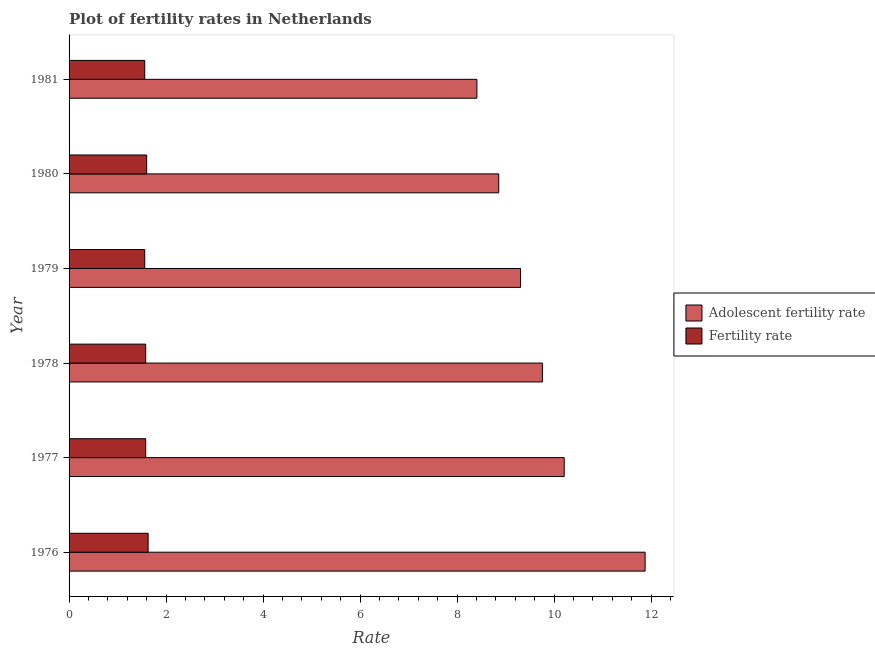How many groups of bars are there?
Your response must be concise. 6. Are the number of bars per tick equal to the number of legend labels?
Ensure brevity in your answer.  Yes. How many bars are there on the 2nd tick from the top?
Offer a very short reply. 2. What is the label of the 4th group of bars from the top?
Your answer should be very brief. 1978. In how many cases, is the number of bars for a given year not equal to the number of legend labels?
Your response must be concise. 0. What is the adolescent fertility rate in 1978?
Give a very brief answer. 9.76. Across all years, what is the maximum fertility rate?
Ensure brevity in your answer.  1.63. Across all years, what is the minimum fertility rate?
Make the answer very short. 1.56. In which year was the adolescent fertility rate maximum?
Make the answer very short. 1976. What is the total fertility rate in the graph?
Your response must be concise. 9.51. What is the difference between the fertility rate in 1976 and that in 1979?
Provide a short and direct response. 0.07. What is the difference between the fertility rate in 1976 and the adolescent fertility rate in 1978?
Provide a short and direct response. -8.13. What is the average fertility rate per year?
Provide a short and direct response. 1.58. In the year 1976, what is the difference between the adolescent fertility rate and fertility rate?
Make the answer very short. 10.25. In how many years, is the fertility rate greater than 6 ?
Your response must be concise. 0. What is the ratio of the fertility rate in 1976 to that in 1981?
Provide a short and direct response. 1.04. Is the fertility rate in 1976 less than that in 1977?
Ensure brevity in your answer.  No. Is the difference between the adolescent fertility rate in 1978 and 1981 greater than the difference between the fertility rate in 1978 and 1981?
Your answer should be very brief. Yes. What is the difference between the highest and the second highest adolescent fertility rate?
Ensure brevity in your answer.  1.67. What is the difference between the highest and the lowest fertility rate?
Give a very brief answer. 0.07. What does the 2nd bar from the top in 1980 represents?
Make the answer very short. Adolescent fertility rate. What does the 1st bar from the bottom in 1977 represents?
Your answer should be very brief. Adolescent fertility rate. Are all the bars in the graph horizontal?
Your answer should be compact. Yes. Does the graph contain grids?
Ensure brevity in your answer.  No. How many legend labels are there?
Keep it short and to the point. 2. How are the legend labels stacked?
Provide a succinct answer. Vertical. What is the title of the graph?
Ensure brevity in your answer.  Plot of fertility rates in Netherlands. What is the label or title of the X-axis?
Your answer should be compact. Rate. What is the label or title of the Y-axis?
Your answer should be very brief. Year. What is the Rate of Adolescent fertility rate in 1976?
Provide a succinct answer. 11.88. What is the Rate in Fertility rate in 1976?
Your response must be concise. 1.63. What is the Rate of Adolescent fertility rate in 1977?
Your answer should be very brief. 10.21. What is the Rate of Fertility rate in 1977?
Ensure brevity in your answer.  1.58. What is the Rate in Adolescent fertility rate in 1978?
Keep it short and to the point. 9.76. What is the Rate in Fertility rate in 1978?
Give a very brief answer. 1.58. What is the Rate in Adolescent fertility rate in 1979?
Provide a succinct answer. 9.31. What is the Rate in Fertility rate in 1979?
Keep it short and to the point. 1.56. What is the Rate in Adolescent fertility rate in 1980?
Make the answer very short. 8.86. What is the Rate of Fertility rate in 1980?
Your answer should be compact. 1.6. What is the Rate in Adolescent fertility rate in 1981?
Offer a very short reply. 8.41. What is the Rate in Fertility rate in 1981?
Your answer should be very brief. 1.56. Across all years, what is the maximum Rate of Adolescent fertility rate?
Provide a short and direct response. 11.88. Across all years, what is the maximum Rate of Fertility rate?
Make the answer very short. 1.63. Across all years, what is the minimum Rate of Adolescent fertility rate?
Offer a terse response. 8.41. Across all years, what is the minimum Rate of Fertility rate?
Offer a very short reply. 1.56. What is the total Rate in Adolescent fertility rate in the graph?
Offer a terse response. 58.42. What is the total Rate of Fertility rate in the graph?
Offer a very short reply. 9.51. What is the difference between the Rate of Adolescent fertility rate in 1976 and that in 1977?
Provide a succinct answer. 1.67. What is the difference between the Rate of Adolescent fertility rate in 1976 and that in 1978?
Your answer should be compact. 2.12. What is the difference between the Rate in Adolescent fertility rate in 1976 and that in 1979?
Offer a very short reply. 2.57. What is the difference between the Rate of Fertility rate in 1976 and that in 1979?
Offer a very short reply. 0.07. What is the difference between the Rate of Adolescent fertility rate in 1976 and that in 1980?
Provide a short and direct response. 3.02. What is the difference between the Rate in Fertility rate in 1976 and that in 1980?
Provide a short and direct response. 0.03. What is the difference between the Rate of Adolescent fertility rate in 1976 and that in 1981?
Your response must be concise. 3.47. What is the difference between the Rate of Fertility rate in 1976 and that in 1981?
Provide a short and direct response. 0.07. What is the difference between the Rate in Adolescent fertility rate in 1977 and that in 1978?
Provide a succinct answer. 0.45. What is the difference between the Rate in Adolescent fertility rate in 1977 and that in 1979?
Offer a terse response. 0.9. What is the difference between the Rate in Adolescent fertility rate in 1977 and that in 1980?
Ensure brevity in your answer.  1.35. What is the difference between the Rate in Fertility rate in 1977 and that in 1980?
Give a very brief answer. -0.02. What is the difference between the Rate of Adolescent fertility rate in 1978 and that in 1979?
Offer a terse response. 0.45. What is the difference between the Rate in Fertility rate in 1978 and that in 1980?
Ensure brevity in your answer.  -0.02. What is the difference between the Rate of Adolescent fertility rate in 1978 and that in 1981?
Your response must be concise. 1.35. What is the difference between the Rate in Fertility rate in 1978 and that in 1981?
Offer a very short reply. 0.02. What is the difference between the Rate in Adolescent fertility rate in 1979 and that in 1980?
Your answer should be compact. 0.45. What is the difference between the Rate of Fertility rate in 1979 and that in 1980?
Keep it short and to the point. -0.04. What is the difference between the Rate in Adolescent fertility rate in 1979 and that in 1981?
Your response must be concise. 0.9. What is the difference between the Rate of Adolescent fertility rate in 1980 and that in 1981?
Provide a short and direct response. 0.45. What is the difference between the Rate in Adolescent fertility rate in 1976 and the Rate in Fertility rate in 1977?
Offer a very short reply. 10.3. What is the difference between the Rate of Adolescent fertility rate in 1976 and the Rate of Fertility rate in 1978?
Your answer should be compact. 10.3. What is the difference between the Rate of Adolescent fertility rate in 1976 and the Rate of Fertility rate in 1979?
Offer a terse response. 10.32. What is the difference between the Rate of Adolescent fertility rate in 1976 and the Rate of Fertility rate in 1980?
Your response must be concise. 10.28. What is the difference between the Rate in Adolescent fertility rate in 1976 and the Rate in Fertility rate in 1981?
Provide a succinct answer. 10.32. What is the difference between the Rate of Adolescent fertility rate in 1977 and the Rate of Fertility rate in 1978?
Keep it short and to the point. 8.63. What is the difference between the Rate in Adolescent fertility rate in 1977 and the Rate in Fertility rate in 1979?
Ensure brevity in your answer.  8.65. What is the difference between the Rate in Adolescent fertility rate in 1977 and the Rate in Fertility rate in 1980?
Make the answer very short. 8.61. What is the difference between the Rate of Adolescent fertility rate in 1977 and the Rate of Fertility rate in 1981?
Provide a succinct answer. 8.65. What is the difference between the Rate in Adolescent fertility rate in 1978 and the Rate in Fertility rate in 1979?
Make the answer very short. 8.2. What is the difference between the Rate in Adolescent fertility rate in 1978 and the Rate in Fertility rate in 1980?
Provide a short and direct response. 8.16. What is the difference between the Rate of Adolescent fertility rate in 1978 and the Rate of Fertility rate in 1981?
Offer a terse response. 8.2. What is the difference between the Rate of Adolescent fertility rate in 1979 and the Rate of Fertility rate in 1980?
Offer a terse response. 7.71. What is the difference between the Rate in Adolescent fertility rate in 1979 and the Rate in Fertility rate in 1981?
Offer a very short reply. 7.75. What is the difference between the Rate of Adolescent fertility rate in 1980 and the Rate of Fertility rate in 1981?
Give a very brief answer. 7.3. What is the average Rate in Adolescent fertility rate per year?
Make the answer very short. 9.74. What is the average Rate in Fertility rate per year?
Your response must be concise. 1.58. In the year 1976, what is the difference between the Rate in Adolescent fertility rate and Rate in Fertility rate?
Make the answer very short. 10.25. In the year 1977, what is the difference between the Rate of Adolescent fertility rate and Rate of Fertility rate?
Keep it short and to the point. 8.63. In the year 1978, what is the difference between the Rate in Adolescent fertility rate and Rate in Fertility rate?
Your response must be concise. 8.18. In the year 1979, what is the difference between the Rate of Adolescent fertility rate and Rate of Fertility rate?
Provide a short and direct response. 7.75. In the year 1980, what is the difference between the Rate of Adolescent fertility rate and Rate of Fertility rate?
Your response must be concise. 7.26. In the year 1981, what is the difference between the Rate in Adolescent fertility rate and Rate in Fertility rate?
Provide a short and direct response. 6.85. What is the ratio of the Rate in Adolescent fertility rate in 1976 to that in 1977?
Give a very brief answer. 1.16. What is the ratio of the Rate of Fertility rate in 1976 to that in 1977?
Provide a short and direct response. 1.03. What is the ratio of the Rate in Adolescent fertility rate in 1976 to that in 1978?
Ensure brevity in your answer.  1.22. What is the ratio of the Rate in Fertility rate in 1976 to that in 1978?
Ensure brevity in your answer.  1.03. What is the ratio of the Rate of Adolescent fertility rate in 1976 to that in 1979?
Offer a terse response. 1.28. What is the ratio of the Rate of Fertility rate in 1976 to that in 1979?
Your answer should be compact. 1.04. What is the ratio of the Rate in Adolescent fertility rate in 1976 to that in 1980?
Your response must be concise. 1.34. What is the ratio of the Rate in Fertility rate in 1976 to that in 1980?
Make the answer very short. 1.02. What is the ratio of the Rate in Adolescent fertility rate in 1976 to that in 1981?
Offer a very short reply. 1.41. What is the ratio of the Rate of Fertility rate in 1976 to that in 1981?
Give a very brief answer. 1.04. What is the ratio of the Rate in Adolescent fertility rate in 1977 to that in 1978?
Your answer should be very brief. 1.05. What is the ratio of the Rate in Fertility rate in 1977 to that in 1978?
Give a very brief answer. 1. What is the ratio of the Rate of Adolescent fertility rate in 1977 to that in 1979?
Make the answer very short. 1.1. What is the ratio of the Rate in Fertility rate in 1977 to that in 1979?
Your response must be concise. 1.01. What is the ratio of the Rate in Adolescent fertility rate in 1977 to that in 1980?
Give a very brief answer. 1.15. What is the ratio of the Rate in Fertility rate in 1977 to that in 1980?
Your response must be concise. 0.99. What is the ratio of the Rate in Adolescent fertility rate in 1977 to that in 1981?
Provide a succinct answer. 1.21. What is the ratio of the Rate in Fertility rate in 1977 to that in 1981?
Keep it short and to the point. 1.01. What is the ratio of the Rate of Adolescent fertility rate in 1978 to that in 1979?
Ensure brevity in your answer.  1.05. What is the ratio of the Rate of Fertility rate in 1978 to that in 1979?
Give a very brief answer. 1.01. What is the ratio of the Rate of Adolescent fertility rate in 1978 to that in 1980?
Give a very brief answer. 1.1. What is the ratio of the Rate in Fertility rate in 1978 to that in 1980?
Your response must be concise. 0.99. What is the ratio of the Rate in Adolescent fertility rate in 1978 to that in 1981?
Provide a succinct answer. 1.16. What is the ratio of the Rate of Fertility rate in 1978 to that in 1981?
Keep it short and to the point. 1.01. What is the ratio of the Rate in Adolescent fertility rate in 1979 to that in 1980?
Provide a succinct answer. 1.05. What is the ratio of the Rate in Fertility rate in 1979 to that in 1980?
Ensure brevity in your answer.  0.97. What is the ratio of the Rate of Adolescent fertility rate in 1979 to that in 1981?
Give a very brief answer. 1.11. What is the ratio of the Rate in Fertility rate in 1979 to that in 1981?
Your answer should be very brief. 1. What is the ratio of the Rate in Adolescent fertility rate in 1980 to that in 1981?
Provide a short and direct response. 1.05. What is the ratio of the Rate in Fertility rate in 1980 to that in 1981?
Provide a succinct answer. 1.03. What is the difference between the highest and the second highest Rate in Adolescent fertility rate?
Your answer should be compact. 1.67. What is the difference between the highest and the lowest Rate in Adolescent fertility rate?
Give a very brief answer. 3.47. What is the difference between the highest and the lowest Rate of Fertility rate?
Your answer should be compact. 0.07. 